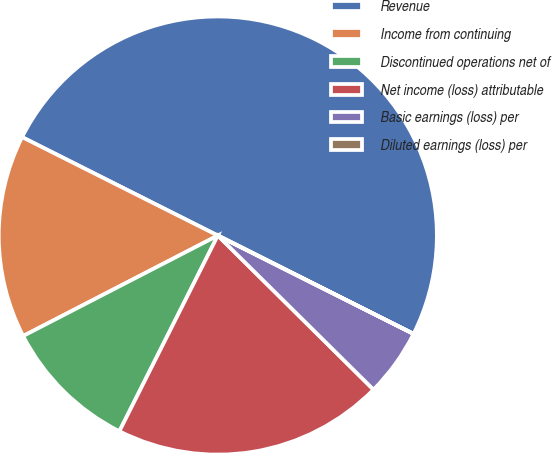<chart> <loc_0><loc_0><loc_500><loc_500><pie_chart><fcel>Revenue<fcel>Income from continuing<fcel>Discontinued operations net of<fcel>Net income (loss) attributable<fcel>Basic earnings (loss) per<fcel>Diluted earnings (loss) per<nl><fcel>49.99%<fcel>15.0%<fcel>10.0%<fcel>20.0%<fcel>5.0%<fcel>0.01%<nl></chart> 